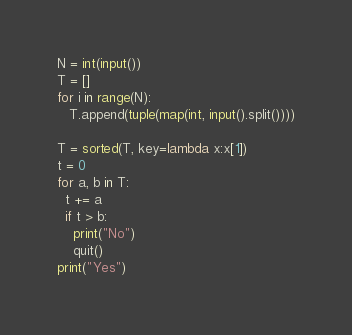<code> <loc_0><loc_0><loc_500><loc_500><_Python_>N = int(input())
T = []
for i in range(N):
   T.append(tuple(map(int, input().split())))

T = sorted(T, key=lambda x:x[1])
t = 0
for a, b in T:
  t += a
  if t > b:
    print("No")
    quit()
print("Yes")</code> 